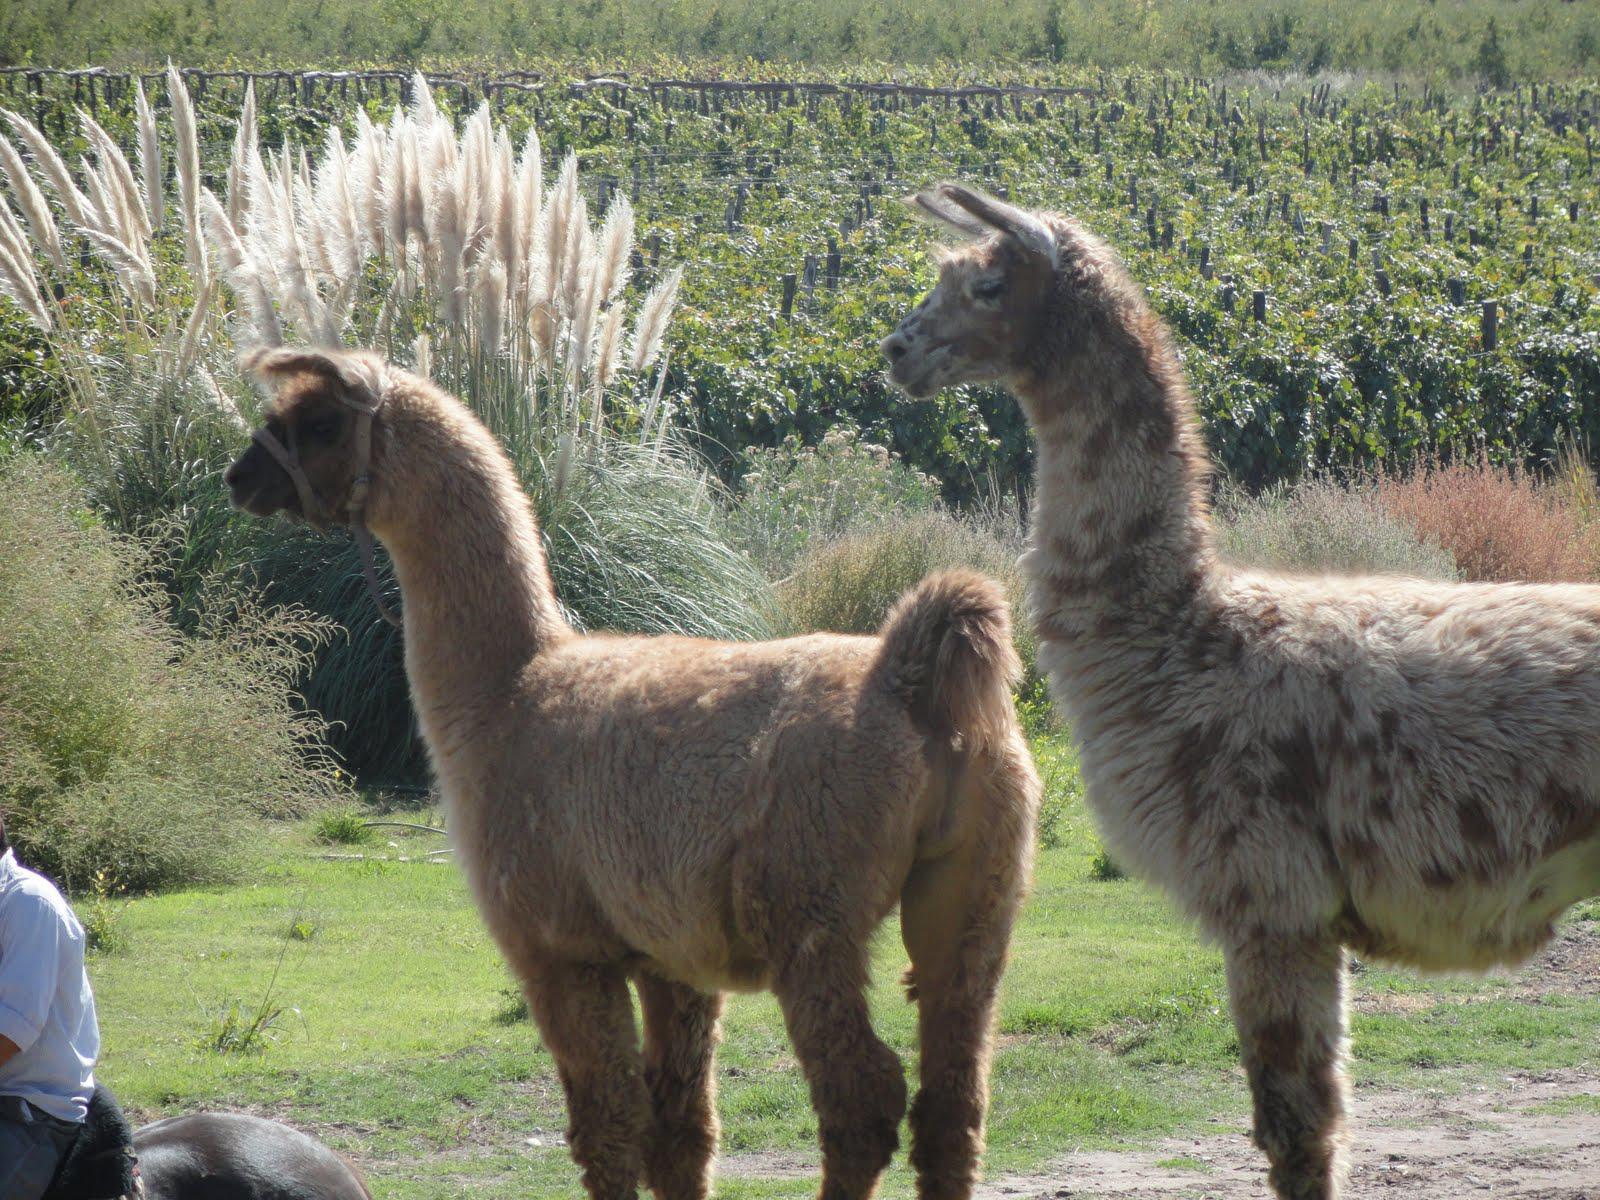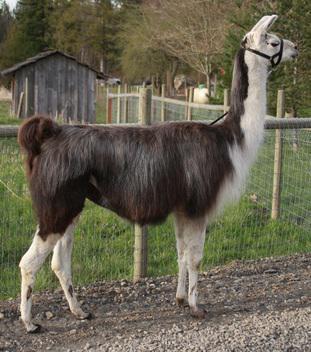The first image is the image on the left, the second image is the image on the right. Given the left and right images, does the statement "One llama is looking to the right." hold true? Answer yes or no. Yes. The first image is the image on the left, the second image is the image on the right. Given the left and right images, does the statement "The right image contains one right-facing llama wearing a head harness, and the left image contains two llamas with bodies turned to the left." hold true? Answer yes or no. Yes. 